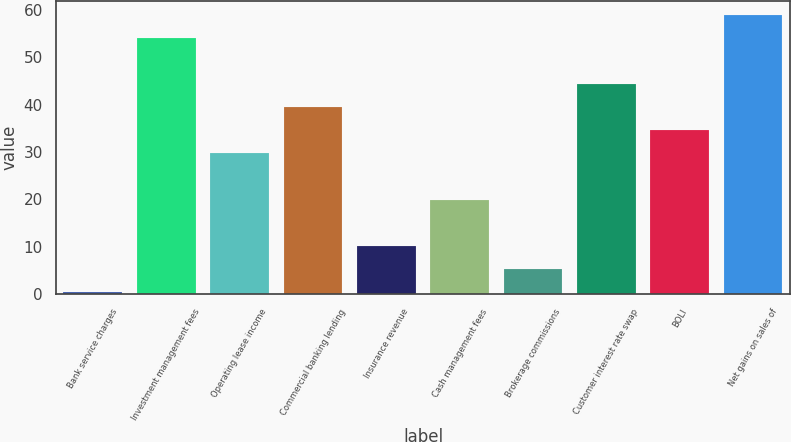<chart> <loc_0><loc_0><loc_500><loc_500><bar_chart><fcel>Bank service charges<fcel>Investment management fees<fcel>Operating lease income<fcel>Commercial banking lending<fcel>Insurance revenue<fcel>Cash management fees<fcel>Brokerage commissions<fcel>Customer interest rate swap<fcel>BOLI<fcel>Net gains on sales of<nl><fcel>0.5<fcel>54.07<fcel>29.72<fcel>39.46<fcel>10.24<fcel>19.98<fcel>5.37<fcel>44.33<fcel>34.59<fcel>58.94<nl></chart> 